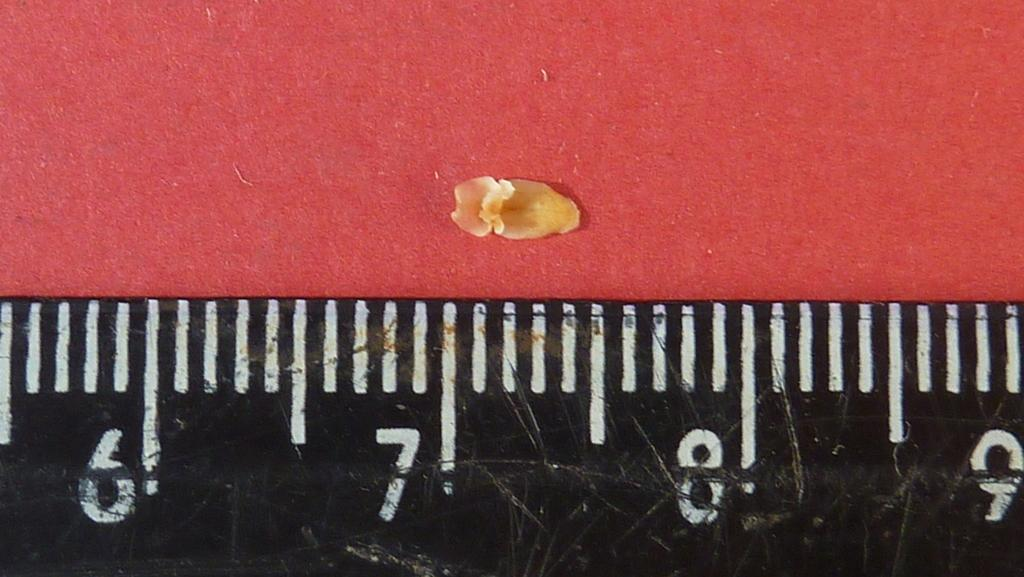<image>
Share a concise interpretation of the image provided. A black ruler is next to a flower petal that is closest to the interval that says 7. 